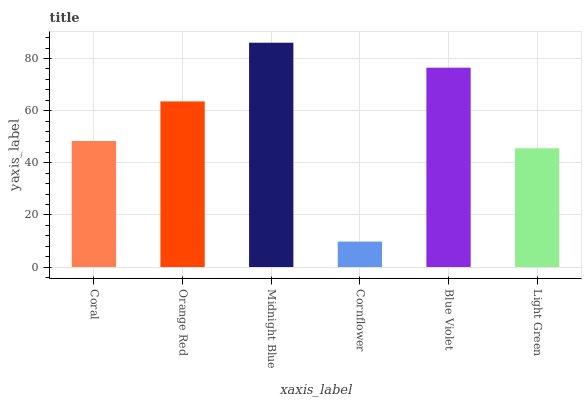Is Cornflower the minimum?
Answer yes or no. Yes. Is Midnight Blue the maximum?
Answer yes or no. Yes. Is Orange Red the minimum?
Answer yes or no. No. Is Orange Red the maximum?
Answer yes or no. No. Is Orange Red greater than Coral?
Answer yes or no. Yes. Is Coral less than Orange Red?
Answer yes or no. Yes. Is Coral greater than Orange Red?
Answer yes or no. No. Is Orange Red less than Coral?
Answer yes or no. No. Is Orange Red the high median?
Answer yes or no. Yes. Is Coral the low median?
Answer yes or no. Yes. Is Light Green the high median?
Answer yes or no. No. Is Blue Violet the low median?
Answer yes or no. No. 